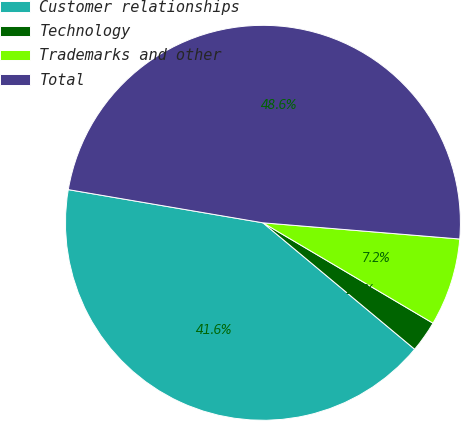Convert chart to OTSL. <chart><loc_0><loc_0><loc_500><loc_500><pie_chart><fcel>Customer relationships<fcel>Technology<fcel>Trademarks and other<fcel>Total<nl><fcel>41.63%<fcel>2.57%<fcel>7.18%<fcel>48.62%<nl></chart> 